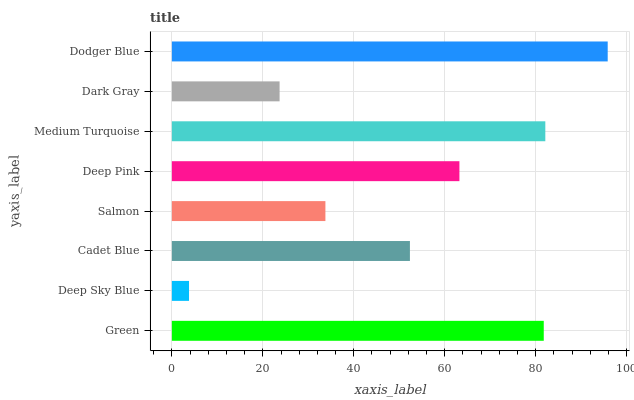Is Deep Sky Blue the minimum?
Answer yes or no. Yes. Is Dodger Blue the maximum?
Answer yes or no. Yes. Is Cadet Blue the minimum?
Answer yes or no. No. Is Cadet Blue the maximum?
Answer yes or no. No. Is Cadet Blue greater than Deep Sky Blue?
Answer yes or no. Yes. Is Deep Sky Blue less than Cadet Blue?
Answer yes or no. Yes. Is Deep Sky Blue greater than Cadet Blue?
Answer yes or no. No. Is Cadet Blue less than Deep Sky Blue?
Answer yes or no. No. Is Deep Pink the high median?
Answer yes or no. Yes. Is Cadet Blue the low median?
Answer yes or no. Yes. Is Green the high median?
Answer yes or no. No. Is Salmon the low median?
Answer yes or no. No. 